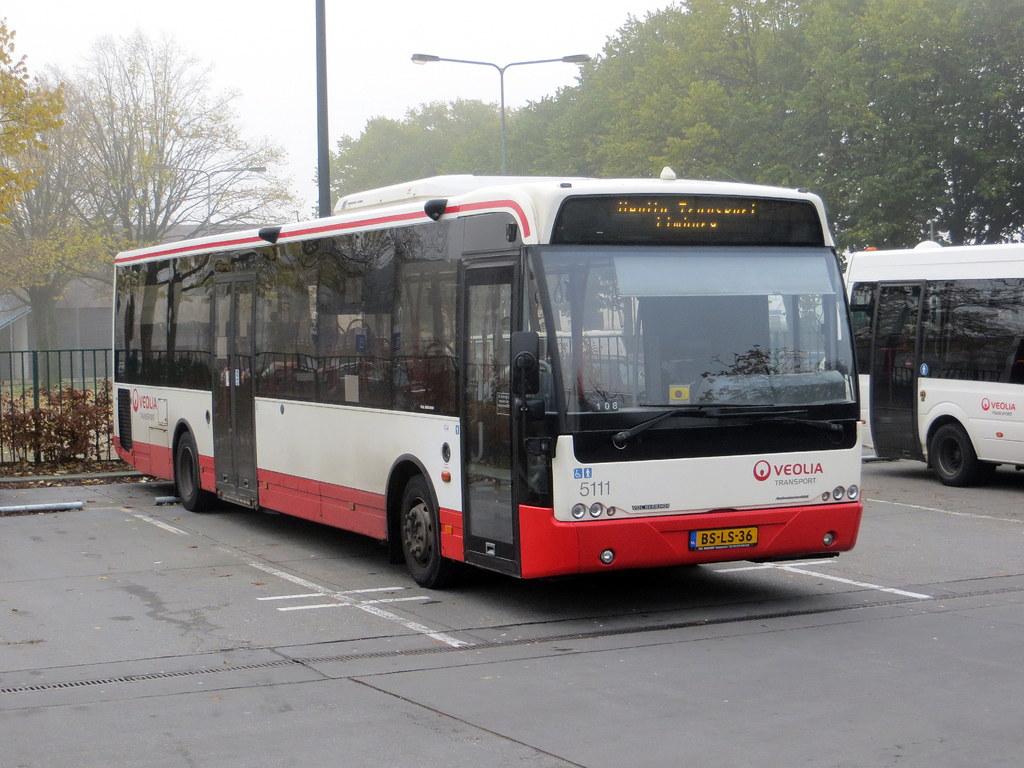What is the bus's license plate number?
Offer a terse response. Bs-ls-36. What bus number is this?
Your answer should be very brief. 5111. 